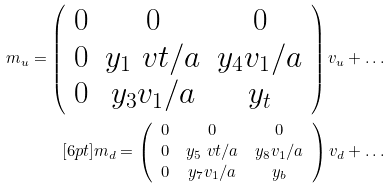Convert formula to latex. <formula><loc_0><loc_0><loc_500><loc_500>m _ { u } = \left ( \begin{array} { c c c } 0 & 0 & 0 \\ 0 & y _ { 1 } \ v t / \L a & y _ { 4 } v _ { 1 } / \L a \\ 0 & y _ { 3 } v _ { 1 } / \L a & y _ { t } \\ \end{array} \right ) v _ { u } + \dots \\ [ 6 p t ] m _ { d } = \left ( \begin{array} { c c c } 0 & 0 & 0 \\ 0 & y _ { 5 } \ v t / \L a & y _ { 8 } v _ { 1 } / \L a \\ 0 & y _ { 7 } v _ { 1 } / \L a & y _ { b } \\ \end{array} \right ) v _ { d } + \dots</formula> 